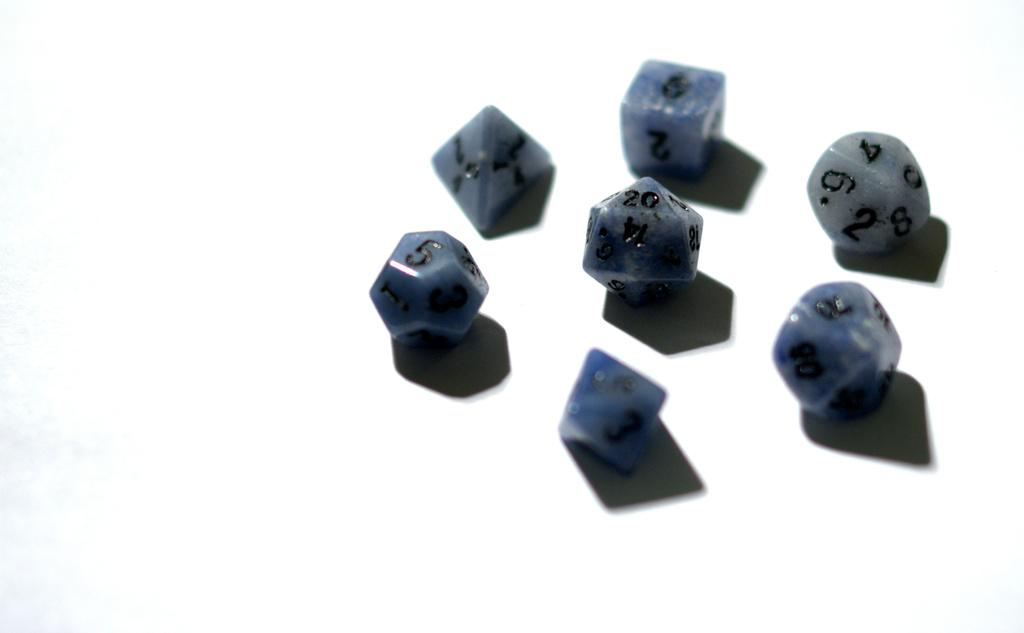What objects can be seen in the picture? There are dice in the picture. Can you describe the dice in more detail? The dice have different shape structures. What type of silk is used to wrap the dice in the picture? There is no silk present in the image, as it features dice with different shape structures. 